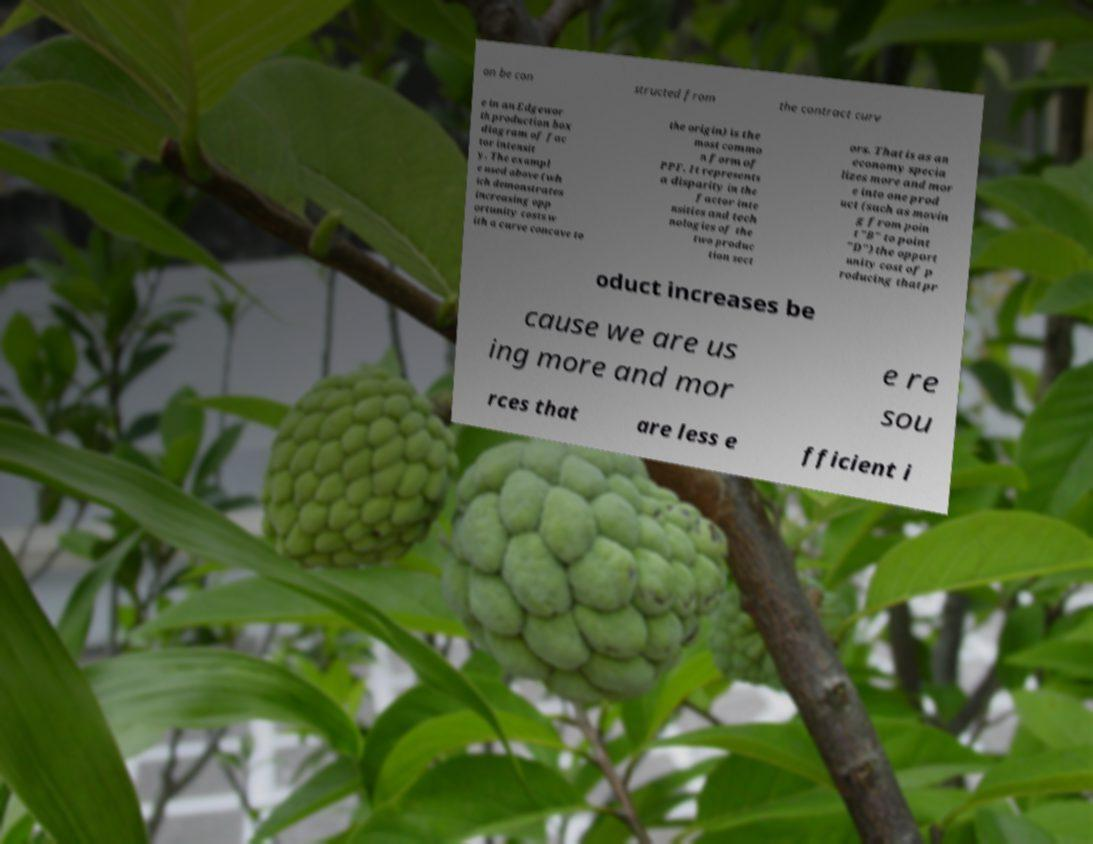Could you assist in decoding the text presented in this image and type it out clearly? an be con structed from the contract curv e in an Edgewor th production box diagram of fac tor intensit y. The exampl e used above (wh ich demonstrates increasing opp ortunity costs w ith a curve concave to the origin) is the most commo n form of PPF. It represents a disparity in the factor inte nsities and tech nologies of the two produc tion sect ors. That is as an economy specia lizes more and mor e into one prod uct (such as movin g from poin t "B" to point "D") the opport unity cost of p roducing that pr oduct increases be cause we are us ing more and mor e re sou rces that are less e fficient i 